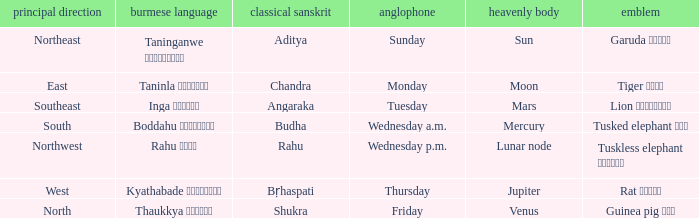What is the cardinal direction associated with Venus? North. 